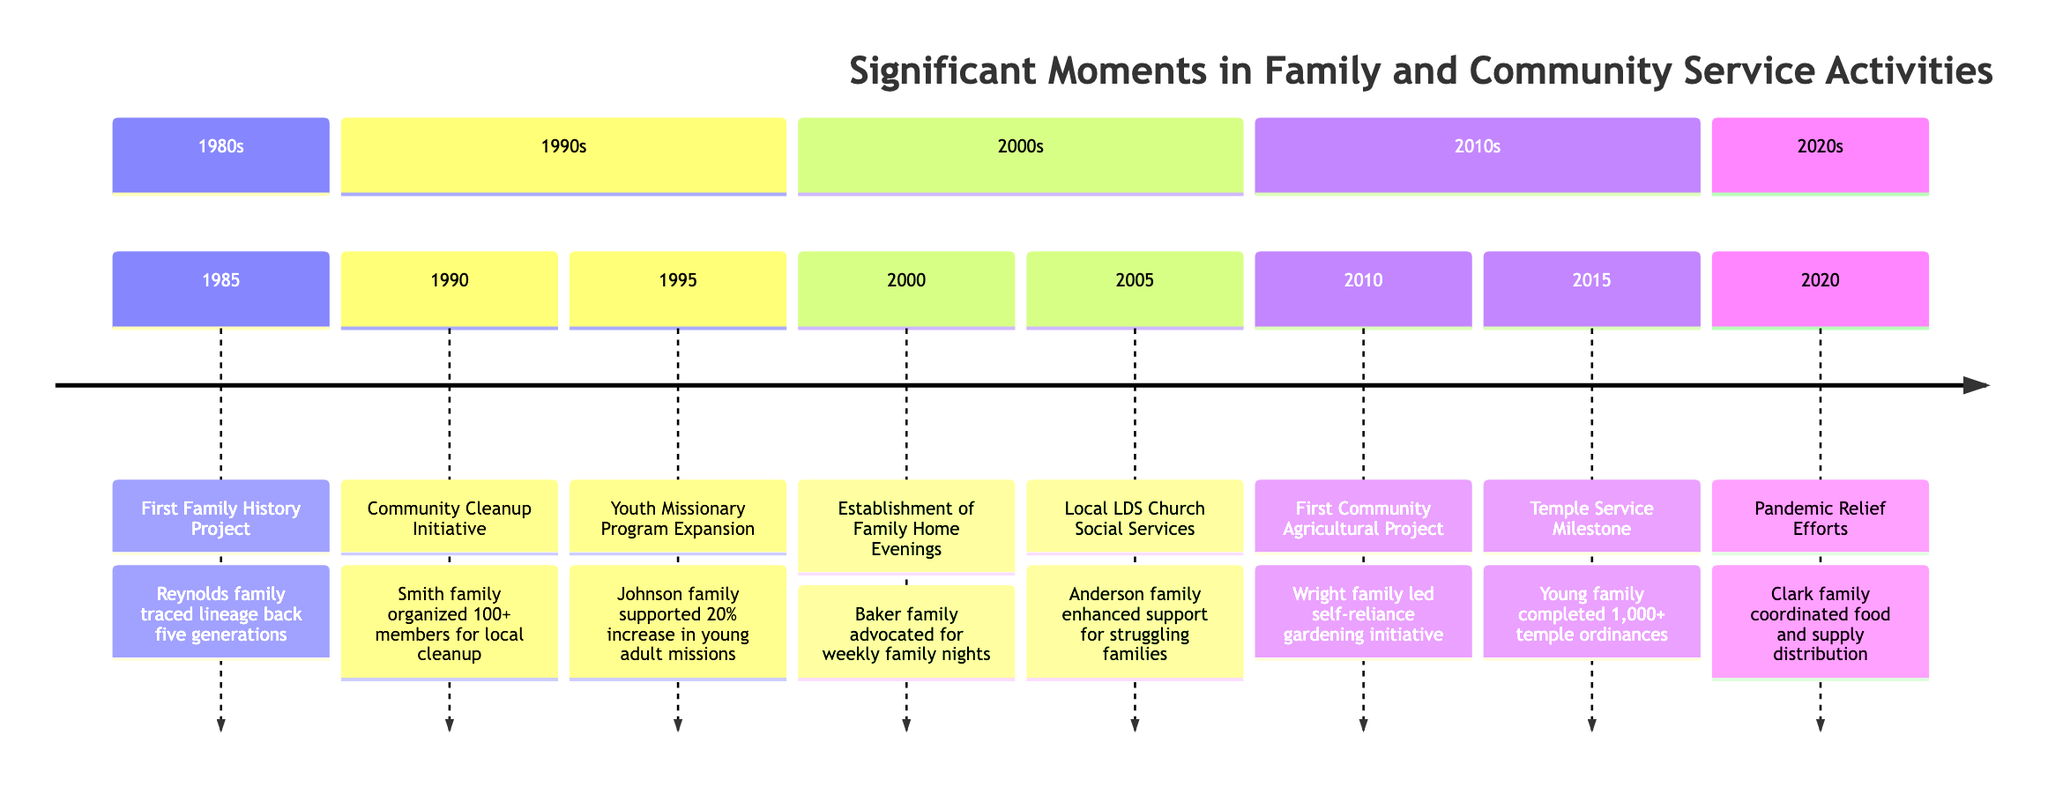What year did the First Family History Project take place? The timeline indicates that the First Family History Project was initiated in 1985. Therefore, the year is clearly stated in the timeline as the first event listed.
Answer: 1985 How many community members participated in the Community Cleanup Initiative? The timeline mentions that over 100 community members were involved in the Community Cleanup Initiative organized by the Smith family. This specific number is highlighted as part of the event description.
Answer: 100+ What was the primary focus of the Local LDS Church Social Services in 2005? In the description for the Local LDS Church Social Services, it is stated that the Anderson family enhanced support for homeless and struggling families. This indicates the focus of the social services initiative.
Answer: Support for homeless and struggling families Which family initiated the First Community Agricultural Project? According to the timeline, the First Community Agricultural Project was led by the Wright family, confirming their role as the initiators of the project.
Answer: Wright family What percentage increase in young adults serving missions was associated with the Youth Missionary Program Expansion? The timeline explicitly states there was a 20% increase in young adults serving missions due to the Johnson family's support during the Youth Missionary Program Expansion.
Answer: 20% Which family coordinated food and supply distribution during the pandemic in 2020? The description for the 2020 pandemic relief efforts indicates that the Clark family coordinated these efforts, directly associating them with the initiative during that year.
Answer: Clark family In what year was there a milestone reached in temple service? The timeline notes that in 2015, the Young family reached a milestone by completing over 1,000 ordinances in the local LDS temple. Therefore, the year of this significant milestone is 2015.
Answer: 2015 What key activity did the Baker family advocate for in 2000? The timeline mentions that in 2000, the Baker family advocated for the establishment of Family Home Evenings, which highlights their promotion of this key family activity.
Answer: Family Home Evenings How many ordinances did the Young family complete in 2015? The timeline describes that the Young family completed over 1,000 ordinances in the local LDS temple, indicating the specific accomplishment achieved during that year.
Answer: 1,000+ 